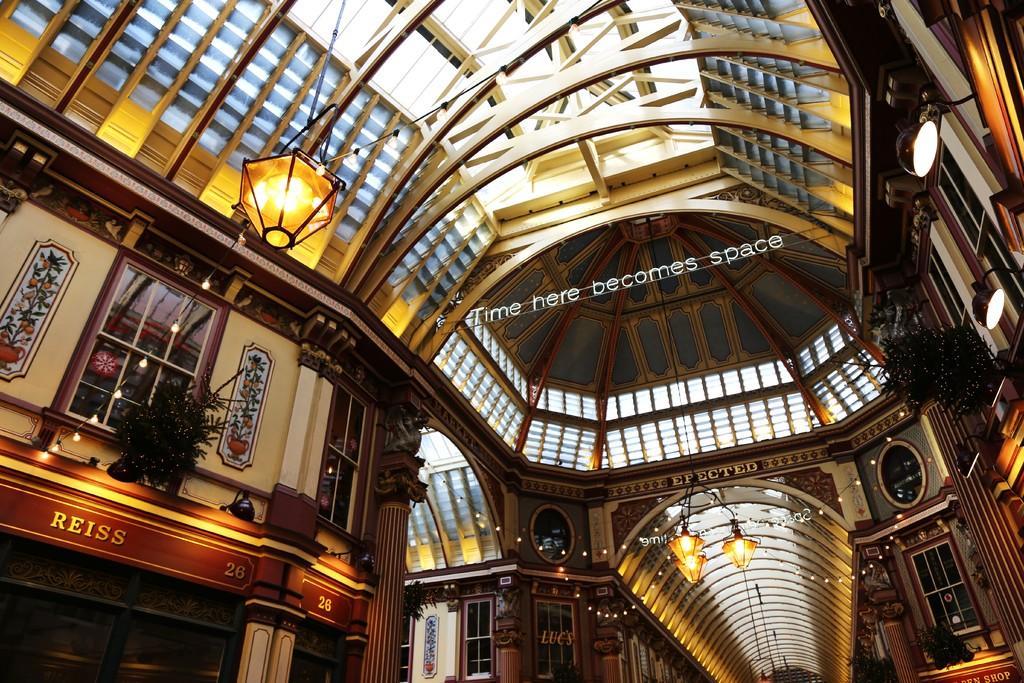Can you describe this image briefly? In this image we can see a roof, lights, pillars, windows, walls and plants. In the middle of the image, we can see some text. 